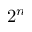<formula> <loc_0><loc_0><loc_500><loc_500>2 ^ { n }</formula> 